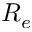Convert formula to latex. <formula><loc_0><loc_0><loc_500><loc_500>R _ { e }</formula> 